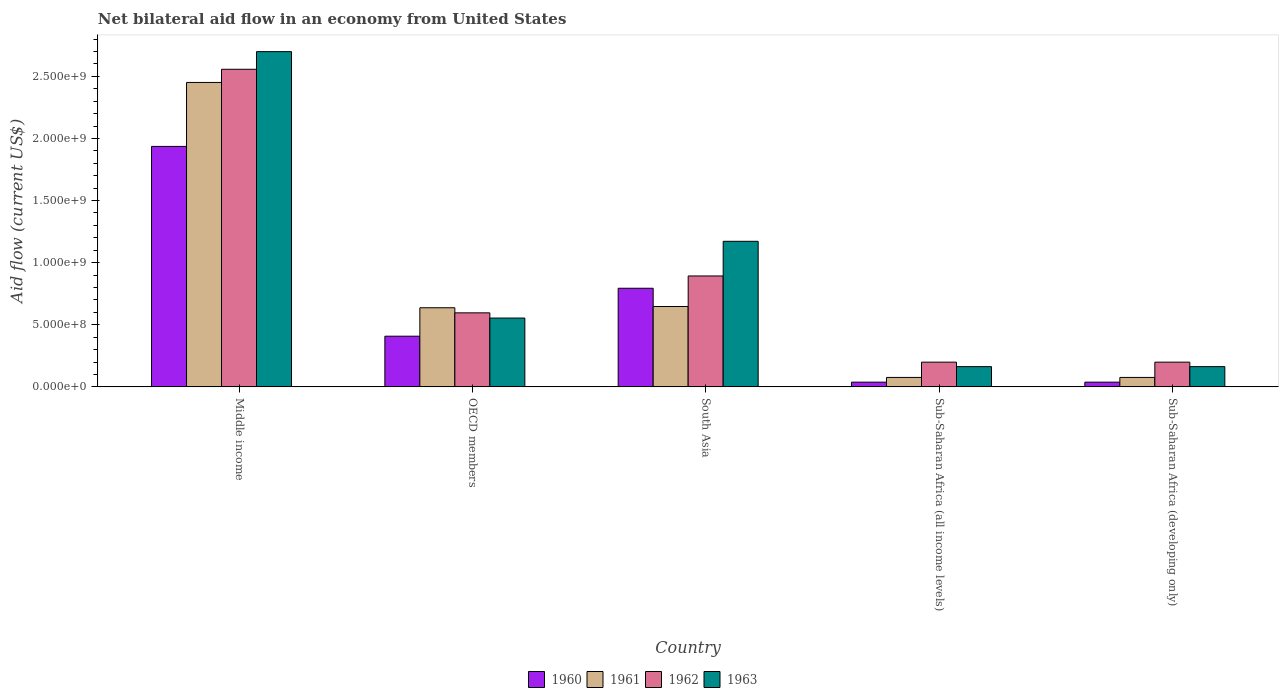How many different coloured bars are there?
Your answer should be compact. 4. How many bars are there on the 2nd tick from the left?
Your answer should be very brief. 4. What is the label of the 1st group of bars from the left?
Offer a very short reply. Middle income. What is the net bilateral aid flow in 1960 in Sub-Saharan Africa (all income levels)?
Keep it short and to the point. 3.80e+07. Across all countries, what is the maximum net bilateral aid flow in 1962?
Your answer should be compact. 2.56e+09. Across all countries, what is the minimum net bilateral aid flow in 1963?
Provide a succinct answer. 1.63e+08. In which country was the net bilateral aid flow in 1960 minimum?
Your response must be concise. Sub-Saharan Africa (all income levels). What is the total net bilateral aid flow in 1962 in the graph?
Offer a terse response. 4.44e+09. What is the difference between the net bilateral aid flow in 1962 in Middle income and that in South Asia?
Give a very brief answer. 1.66e+09. What is the difference between the net bilateral aid flow in 1960 in South Asia and the net bilateral aid flow in 1963 in Sub-Saharan Africa (developing only)?
Ensure brevity in your answer.  6.31e+08. What is the average net bilateral aid flow in 1961 per country?
Offer a terse response. 7.77e+08. What is the difference between the net bilateral aid flow of/in 1961 and net bilateral aid flow of/in 1962 in OECD members?
Your answer should be compact. 4.10e+07. In how many countries, is the net bilateral aid flow in 1961 greater than 500000000 US$?
Make the answer very short. 3. What is the ratio of the net bilateral aid flow in 1960 in Middle income to that in South Asia?
Your answer should be very brief. 2.44. What is the difference between the highest and the second highest net bilateral aid flow in 1962?
Your response must be concise. 1.96e+09. What is the difference between the highest and the lowest net bilateral aid flow in 1963?
Your answer should be very brief. 2.54e+09. Is the sum of the net bilateral aid flow in 1962 in Middle income and South Asia greater than the maximum net bilateral aid flow in 1961 across all countries?
Provide a succinct answer. Yes. Is it the case that in every country, the sum of the net bilateral aid flow in 1961 and net bilateral aid flow in 1963 is greater than the sum of net bilateral aid flow in 1962 and net bilateral aid flow in 1960?
Your response must be concise. No. What does the 3rd bar from the right in Sub-Saharan Africa (all income levels) represents?
Offer a terse response. 1961. How many bars are there?
Make the answer very short. 20. How many countries are there in the graph?
Your answer should be very brief. 5. What is the difference between two consecutive major ticks on the Y-axis?
Keep it short and to the point. 5.00e+08. Are the values on the major ticks of Y-axis written in scientific E-notation?
Your answer should be compact. Yes. Does the graph contain any zero values?
Offer a very short reply. No. Where does the legend appear in the graph?
Offer a very short reply. Bottom center. How are the legend labels stacked?
Your answer should be compact. Horizontal. What is the title of the graph?
Offer a terse response. Net bilateral aid flow in an economy from United States. What is the label or title of the Y-axis?
Make the answer very short. Aid flow (current US$). What is the Aid flow (current US$) of 1960 in Middle income?
Offer a very short reply. 1.94e+09. What is the Aid flow (current US$) of 1961 in Middle income?
Keep it short and to the point. 2.45e+09. What is the Aid flow (current US$) in 1962 in Middle income?
Offer a terse response. 2.56e+09. What is the Aid flow (current US$) of 1963 in Middle income?
Offer a terse response. 2.70e+09. What is the Aid flow (current US$) in 1960 in OECD members?
Ensure brevity in your answer.  4.08e+08. What is the Aid flow (current US$) in 1961 in OECD members?
Offer a very short reply. 6.37e+08. What is the Aid flow (current US$) of 1962 in OECD members?
Your answer should be compact. 5.96e+08. What is the Aid flow (current US$) of 1963 in OECD members?
Give a very brief answer. 5.54e+08. What is the Aid flow (current US$) of 1960 in South Asia?
Your answer should be compact. 7.94e+08. What is the Aid flow (current US$) in 1961 in South Asia?
Keep it short and to the point. 6.47e+08. What is the Aid flow (current US$) of 1962 in South Asia?
Keep it short and to the point. 8.93e+08. What is the Aid flow (current US$) of 1963 in South Asia?
Offer a terse response. 1.17e+09. What is the Aid flow (current US$) in 1960 in Sub-Saharan Africa (all income levels)?
Your answer should be very brief. 3.80e+07. What is the Aid flow (current US$) of 1961 in Sub-Saharan Africa (all income levels)?
Your answer should be very brief. 7.60e+07. What is the Aid flow (current US$) of 1962 in Sub-Saharan Africa (all income levels)?
Your answer should be very brief. 1.99e+08. What is the Aid flow (current US$) in 1963 in Sub-Saharan Africa (all income levels)?
Keep it short and to the point. 1.63e+08. What is the Aid flow (current US$) of 1960 in Sub-Saharan Africa (developing only)?
Your answer should be compact. 3.80e+07. What is the Aid flow (current US$) in 1961 in Sub-Saharan Africa (developing only)?
Provide a short and direct response. 7.60e+07. What is the Aid flow (current US$) of 1962 in Sub-Saharan Africa (developing only)?
Your response must be concise. 1.99e+08. What is the Aid flow (current US$) of 1963 in Sub-Saharan Africa (developing only)?
Offer a very short reply. 1.63e+08. Across all countries, what is the maximum Aid flow (current US$) in 1960?
Provide a short and direct response. 1.94e+09. Across all countries, what is the maximum Aid flow (current US$) in 1961?
Your response must be concise. 2.45e+09. Across all countries, what is the maximum Aid flow (current US$) of 1962?
Offer a terse response. 2.56e+09. Across all countries, what is the maximum Aid flow (current US$) of 1963?
Make the answer very short. 2.70e+09. Across all countries, what is the minimum Aid flow (current US$) in 1960?
Your answer should be very brief. 3.80e+07. Across all countries, what is the minimum Aid flow (current US$) of 1961?
Your answer should be compact. 7.60e+07. Across all countries, what is the minimum Aid flow (current US$) of 1962?
Provide a short and direct response. 1.99e+08. Across all countries, what is the minimum Aid flow (current US$) of 1963?
Your answer should be very brief. 1.63e+08. What is the total Aid flow (current US$) of 1960 in the graph?
Your answer should be very brief. 3.21e+09. What is the total Aid flow (current US$) in 1961 in the graph?
Provide a short and direct response. 3.89e+09. What is the total Aid flow (current US$) of 1962 in the graph?
Ensure brevity in your answer.  4.44e+09. What is the total Aid flow (current US$) in 1963 in the graph?
Make the answer very short. 4.75e+09. What is the difference between the Aid flow (current US$) in 1960 in Middle income and that in OECD members?
Keep it short and to the point. 1.53e+09. What is the difference between the Aid flow (current US$) of 1961 in Middle income and that in OECD members?
Your response must be concise. 1.81e+09. What is the difference between the Aid flow (current US$) of 1962 in Middle income and that in OECD members?
Provide a short and direct response. 1.96e+09. What is the difference between the Aid flow (current US$) of 1963 in Middle income and that in OECD members?
Your answer should be very brief. 2.14e+09. What is the difference between the Aid flow (current US$) in 1960 in Middle income and that in South Asia?
Provide a short and direct response. 1.14e+09. What is the difference between the Aid flow (current US$) in 1961 in Middle income and that in South Asia?
Provide a short and direct response. 1.80e+09. What is the difference between the Aid flow (current US$) in 1962 in Middle income and that in South Asia?
Offer a terse response. 1.66e+09. What is the difference between the Aid flow (current US$) of 1963 in Middle income and that in South Asia?
Your answer should be very brief. 1.53e+09. What is the difference between the Aid flow (current US$) in 1960 in Middle income and that in Sub-Saharan Africa (all income levels)?
Make the answer very short. 1.90e+09. What is the difference between the Aid flow (current US$) in 1961 in Middle income and that in Sub-Saharan Africa (all income levels)?
Offer a very short reply. 2.38e+09. What is the difference between the Aid flow (current US$) of 1962 in Middle income and that in Sub-Saharan Africa (all income levels)?
Provide a succinct answer. 2.36e+09. What is the difference between the Aid flow (current US$) of 1963 in Middle income and that in Sub-Saharan Africa (all income levels)?
Your response must be concise. 2.54e+09. What is the difference between the Aid flow (current US$) in 1960 in Middle income and that in Sub-Saharan Africa (developing only)?
Ensure brevity in your answer.  1.90e+09. What is the difference between the Aid flow (current US$) of 1961 in Middle income and that in Sub-Saharan Africa (developing only)?
Provide a short and direct response. 2.38e+09. What is the difference between the Aid flow (current US$) in 1962 in Middle income and that in Sub-Saharan Africa (developing only)?
Keep it short and to the point. 2.36e+09. What is the difference between the Aid flow (current US$) in 1963 in Middle income and that in Sub-Saharan Africa (developing only)?
Give a very brief answer. 2.54e+09. What is the difference between the Aid flow (current US$) of 1960 in OECD members and that in South Asia?
Make the answer very short. -3.86e+08. What is the difference between the Aid flow (current US$) of 1961 in OECD members and that in South Asia?
Give a very brief answer. -1.00e+07. What is the difference between the Aid flow (current US$) of 1962 in OECD members and that in South Asia?
Provide a succinct answer. -2.97e+08. What is the difference between the Aid flow (current US$) of 1963 in OECD members and that in South Asia?
Provide a short and direct response. -6.18e+08. What is the difference between the Aid flow (current US$) of 1960 in OECD members and that in Sub-Saharan Africa (all income levels)?
Ensure brevity in your answer.  3.70e+08. What is the difference between the Aid flow (current US$) in 1961 in OECD members and that in Sub-Saharan Africa (all income levels)?
Offer a terse response. 5.61e+08. What is the difference between the Aid flow (current US$) in 1962 in OECD members and that in Sub-Saharan Africa (all income levels)?
Provide a succinct answer. 3.97e+08. What is the difference between the Aid flow (current US$) in 1963 in OECD members and that in Sub-Saharan Africa (all income levels)?
Make the answer very short. 3.91e+08. What is the difference between the Aid flow (current US$) in 1960 in OECD members and that in Sub-Saharan Africa (developing only)?
Ensure brevity in your answer.  3.70e+08. What is the difference between the Aid flow (current US$) in 1961 in OECD members and that in Sub-Saharan Africa (developing only)?
Your answer should be very brief. 5.61e+08. What is the difference between the Aid flow (current US$) in 1962 in OECD members and that in Sub-Saharan Africa (developing only)?
Your response must be concise. 3.97e+08. What is the difference between the Aid flow (current US$) of 1963 in OECD members and that in Sub-Saharan Africa (developing only)?
Make the answer very short. 3.91e+08. What is the difference between the Aid flow (current US$) in 1960 in South Asia and that in Sub-Saharan Africa (all income levels)?
Your answer should be very brief. 7.56e+08. What is the difference between the Aid flow (current US$) of 1961 in South Asia and that in Sub-Saharan Africa (all income levels)?
Provide a short and direct response. 5.71e+08. What is the difference between the Aid flow (current US$) of 1962 in South Asia and that in Sub-Saharan Africa (all income levels)?
Offer a very short reply. 6.94e+08. What is the difference between the Aid flow (current US$) of 1963 in South Asia and that in Sub-Saharan Africa (all income levels)?
Your answer should be compact. 1.01e+09. What is the difference between the Aid flow (current US$) in 1960 in South Asia and that in Sub-Saharan Africa (developing only)?
Your response must be concise. 7.56e+08. What is the difference between the Aid flow (current US$) in 1961 in South Asia and that in Sub-Saharan Africa (developing only)?
Provide a succinct answer. 5.71e+08. What is the difference between the Aid flow (current US$) in 1962 in South Asia and that in Sub-Saharan Africa (developing only)?
Offer a terse response. 6.94e+08. What is the difference between the Aid flow (current US$) in 1963 in South Asia and that in Sub-Saharan Africa (developing only)?
Provide a short and direct response. 1.01e+09. What is the difference between the Aid flow (current US$) in 1960 in Sub-Saharan Africa (all income levels) and that in Sub-Saharan Africa (developing only)?
Offer a terse response. 0. What is the difference between the Aid flow (current US$) in 1961 in Sub-Saharan Africa (all income levels) and that in Sub-Saharan Africa (developing only)?
Keep it short and to the point. 0. What is the difference between the Aid flow (current US$) in 1962 in Sub-Saharan Africa (all income levels) and that in Sub-Saharan Africa (developing only)?
Provide a succinct answer. 0. What is the difference between the Aid flow (current US$) in 1960 in Middle income and the Aid flow (current US$) in 1961 in OECD members?
Your answer should be very brief. 1.30e+09. What is the difference between the Aid flow (current US$) of 1960 in Middle income and the Aid flow (current US$) of 1962 in OECD members?
Your answer should be very brief. 1.34e+09. What is the difference between the Aid flow (current US$) in 1960 in Middle income and the Aid flow (current US$) in 1963 in OECD members?
Make the answer very short. 1.38e+09. What is the difference between the Aid flow (current US$) of 1961 in Middle income and the Aid flow (current US$) of 1962 in OECD members?
Keep it short and to the point. 1.86e+09. What is the difference between the Aid flow (current US$) of 1961 in Middle income and the Aid flow (current US$) of 1963 in OECD members?
Your answer should be very brief. 1.90e+09. What is the difference between the Aid flow (current US$) in 1962 in Middle income and the Aid flow (current US$) in 1963 in OECD members?
Your response must be concise. 2.00e+09. What is the difference between the Aid flow (current US$) in 1960 in Middle income and the Aid flow (current US$) in 1961 in South Asia?
Ensure brevity in your answer.  1.29e+09. What is the difference between the Aid flow (current US$) in 1960 in Middle income and the Aid flow (current US$) in 1962 in South Asia?
Offer a terse response. 1.04e+09. What is the difference between the Aid flow (current US$) of 1960 in Middle income and the Aid flow (current US$) of 1963 in South Asia?
Provide a short and direct response. 7.64e+08. What is the difference between the Aid flow (current US$) in 1961 in Middle income and the Aid flow (current US$) in 1962 in South Asia?
Ensure brevity in your answer.  1.56e+09. What is the difference between the Aid flow (current US$) of 1961 in Middle income and the Aid flow (current US$) of 1963 in South Asia?
Your answer should be very brief. 1.28e+09. What is the difference between the Aid flow (current US$) of 1962 in Middle income and the Aid flow (current US$) of 1963 in South Asia?
Keep it short and to the point. 1.38e+09. What is the difference between the Aid flow (current US$) of 1960 in Middle income and the Aid flow (current US$) of 1961 in Sub-Saharan Africa (all income levels)?
Keep it short and to the point. 1.86e+09. What is the difference between the Aid flow (current US$) of 1960 in Middle income and the Aid flow (current US$) of 1962 in Sub-Saharan Africa (all income levels)?
Offer a terse response. 1.74e+09. What is the difference between the Aid flow (current US$) in 1960 in Middle income and the Aid flow (current US$) in 1963 in Sub-Saharan Africa (all income levels)?
Offer a very short reply. 1.77e+09. What is the difference between the Aid flow (current US$) in 1961 in Middle income and the Aid flow (current US$) in 1962 in Sub-Saharan Africa (all income levels)?
Your answer should be very brief. 2.25e+09. What is the difference between the Aid flow (current US$) in 1961 in Middle income and the Aid flow (current US$) in 1963 in Sub-Saharan Africa (all income levels)?
Ensure brevity in your answer.  2.29e+09. What is the difference between the Aid flow (current US$) in 1962 in Middle income and the Aid flow (current US$) in 1963 in Sub-Saharan Africa (all income levels)?
Your answer should be very brief. 2.39e+09. What is the difference between the Aid flow (current US$) of 1960 in Middle income and the Aid flow (current US$) of 1961 in Sub-Saharan Africa (developing only)?
Ensure brevity in your answer.  1.86e+09. What is the difference between the Aid flow (current US$) of 1960 in Middle income and the Aid flow (current US$) of 1962 in Sub-Saharan Africa (developing only)?
Offer a terse response. 1.74e+09. What is the difference between the Aid flow (current US$) of 1960 in Middle income and the Aid flow (current US$) of 1963 in Sub-Saharan Africa (developing only)?
Make the answer very short. 1.77e+09. What is the difference between the Aid flow (current US$) of 1961 in Middle income and the Aid flow (current US$) of 1962 in Sub-Saharan Africa (developing only)?
Ensure brevity in your answer.  2.25e+09. What is the difference between the Aid flow (current US$) in 1961 in Middle income and the Aid flow (current US$) in 1963 in Sub-Saharan Africa (developing only)?
Your answer should be compact. 2.29e+09. What is the difference between the Aid flow (current US$) in 1962 in Middle income and the Aid flow (current US$) in 1963 in Sub-Saharan Africa (developing only)?
Make the answer very short. 2.39e+09. What is the difference between the Aid flow (current US$) in 1960 in OECD members and the Aid flow (current US$) in 1961 in South Asia?
Ensure brevity in your answer.  -2.39e+08. What is the difference between the Aid flow (current US$) in 1960 in OECD members and the Aid flow (current US$) in 1962 in South Asia?
Keep it short and to the point. -4.85e+08. What is the difference between the Aid flow (current US$) of 1960 in OECD members and the Aid flow (current US$) of 1963 in South Asia?
Your response must be concise. -7.64e+08. What is the difference between the Aid flow (current US$) of 1961 in OECD members and the Aid flow (current US$) of 1962 in South Asia?
Keep it short and to the point. -2.56e+08. What is the difference between the Aid flow (current US$) of 1961 in OECD members and the Aid flow (current US$) of 1963 in South Asia?
Ensure brevity in your answer.  -5.35e+08. What is the difference between the Aid flow (current US$) of 1962 in OECD members and the Aid flow (current US$) of 1963 in South Asia?
Offer a very short reply. -5.76e+08. What is the difference between the Aid flow (current US$) in 1960 in OECD members and the Aid flow (current US$) in 1961 in Sub-Saharan Africa (all income levels)?
Your answer should be compact. 3.32e+08. What is the difference between the Aid flow (current US$) of 1960 in OECD members and the Aid flow (current US$) of 1962 in Sub-Saharan Africa (all income levels)?
Give a very brief answer. 2.09e+08. What is the difference between the Aid flow (current US$) of 1960 in OECD members and the Aid flow (current US$) of 1963 in Sub-Saharan Africa (all income levels)?
Give a very brief answer. 2.45e+08. What is the difference between the Aid flow (current US$) of 1961 in OECD members and the Aid flow (current US$) of 1962 in Sub-Saharan Africa (all income levels)?
Offer a terse response. 4.38e+08. What is the difference between the Aid flow (current US$) in 1961 in OECD members and the Aid flow (current US$) in 1963 in Sub-Saharan Africa (all income levels)?
Your response must be concise. 4.74e+08. What is the difference between the Aid flow (current US$) in 1962 in OECD members and the Aid flow (current US$) in 1963 in Sub-Saharan Africa (all income levels)?
Keep it short and to the point. 4.33e+08. What is the difference between the Aid flow (current US$) of 1960 in OECD members and the Aid flow (current US$) of 1961 in Sub-Saharan Africa (developing only)?
Give a very brief answer. 3.32e+08. What is the difference between the Aid flow (current US$) of 1960 in OECD members and the Aid flow (current US$) of 1962 in Sub-Saharan Africa (developing only)?
Ensure brevity in your answer.  2.09e+08. What is the difference between the Aid flow (current US$) in 1960 in OECD members and the Aid flow (current US$) in 1963 in Sub-Saharan Africa (developing only)?
Ensure brevity in your answer.  2.45e+08. What is the difference between the Aid flow (current US$) of 1961 in OECD members and the Aid flow (current US$) of 1962 in Sub-Saharan Africa (developing only)?
Keep it short and to the point. 4.38e+08. What is the difference between the Aid flow (current US$) of 1961 in OECD members and the Aid flow (current US$) of 1963 in Sub-Saharan Africa (developing only)?
Your response must be concise. 4.74e+08. What is the difference between the Aid flow (current US$) in 1962 in OECD members and the Aid flow (current US$) in 1963 in Sub-Saharan Africa (developing only)?
Make the answer very short. 4.33e+08. What is the difference between the Aid flow (current US$) of 1960 in South Asia and the Aid flow (current US$) of 1961 in Sub-Saharan Africa (all income levels)?
Keep it short and to the point. 7.18e+08. What is the difference between the Aid flow (current US$) in 1960 in South Asia and the Aid flow (current US$) in 1962 in Sub-Saharan Africa (all income levels)?
Ensure brevity in your answer.  5.95e+08. What is the difference between the Aid flow (current US$) in 1960 in South Asia and the Aid flow (current US$) in 1963 in Sub-Saharan Africa (all income levels)?
Offer a very short reply. 6.31e+08. What is the difference between the Aid flow (current US$) of 1961 in South Asia and the Aid flow (current US$) of 1962 in Sub-Saharan Africa (all income levels)?
Your answer should be very brief. 4.48e+08. What is the difference between the Aid flow (current US$) in 1961 in South Asia and the Aid flow (current US$) in 1963 in Sub-Saharan Africa (all income levels)?
Offer a terse response. 4.84e+08. What is the difference between the Aid flow (current US$) in 1962 in South Asia and the Aid flow (current US$) in 1963 in Sub-Saharan Africa (all income levels)?
Give a very brief answer. 7.30e+08. What is the difference between the Aid flow (current US$) in 1960 in South Asia and the Aid flow (current US$) in 1961 in Sub-Saharan Africa (developing only)?
Your answer should be very brief. 7.18e+08. What is the difference between the Aid flow (current US$) of 1960 in South Asia and the Aid flow (current US$) of 1962 in Sub-Saharan Africa (developing only)?
Provide a short and direct response. 5.95e+08. What is the difference between the Aid flow (current US$) of 1960 in South Asia and the Aid flow (current US$) of 1963 in Sub-Saharan Africa (developing only)?
Ensure brevity in your answer.  6.31e+08. What is the difference between the Aid flow (current US$) in 1961 in South Asia and the Aid flow (current US$) in 1962 in Sub-Saharan Africa (developing only)?
Provide a short and direct response. 4.48e+08. What is the difference between the Aid flow (current US$) of 1961 in South Asia and the Aid flow (current US$) of 1963 in Sub-Saharan Africa (developing only)?
Provide a succinct answer. 4.84e+08. What is the difference between the Aid flow (current US$) in 1962 in South Asia and the Aid flow (current US$) in 1963 in Sub-Saharan Africa (developing only)?
Ensure brevity in your answer.  7.30e+08. What is the difference between the Aid flow (current US$) in 1960 in Sub-Saharan Africa (all income levels) and the Aid flow (current US$) in 1961 in Sub-Saharan Africa (developing only)?
Ensure brevity in your answer.  -3.80e+07. What is the difference between the Aid flow (current US$) in 1960 in Sub-Saharan Africa (all income levels) and the Aid flow (current US$) in 1962 in Sub-Saharan Africa (developing only)?
Offer a terse response. -1.61e+08. What is the difference between the Aid flow (current US$) of 1960 in Sub-Saharan Africa (all income levels) and the Aid flow (current US$) of 1963 in Sub-Saharan Africa (developing only)?
Your answer should be very brief. -1.25e+08. What is the difference between the Aid flow (current US$) of 1961 in Sub-Saharan Africa (all income levels) and the Aid flow (current US$) of 1962 in Sub-Saharan Africa (developing only)?
Offer a very short reply. -1.23e+08. What is the difference between the Aid flow (current US$) of 1961 in Sub-Saharan Africa (all income levels) and the Aid flow (current US$) of 1963 in Sub-Saharan Africa (developing only)?
Provide a short and direct response. -8.70e+07. What is the difference between the Aid flow (current US$) in 1962 in Sub-Saharan Africa (all income levels) and the Aid flow (current US$) in 1963 in Sub-Saharan Africa (developing only)?
Make the answer very short. 3.60e+07. What is the average Aid flow (current US$) in 1960 per country?
Offer a terse response. 6.43e+08. What is the average Aid flow (current US$) in 1961 per country?
Your response must be concise. 7.77e+08. What is the average Aid flow (current US$) in 1962 per country?
Your response must be concise. 8.89e+08. What is the average Aid flow (current US$) of 1963 per country?
Your answer should be very brief. 9.50e+08. What is the difference between the Aid flow (current US$) of 1960 and Aid flow (current US$) of 1961 in Middle income?
Your response must be concise. -5.15e+08. What is the difference between the Aid flow (current US$) of 1960 and Aid flow (current US$) of 1962 in Middle income?
Your answer should be compact. -6.21e+08. What is the difference between the Aid flow (current US$) in 1960 and Aid flow (current US$) in 1963 in Middle income?
Provide a succinct answer. -7.63e+08. What is the difference between the Aid flow (current US$) of 1961 and Aid flow (current US$) of 1962 in Middle income?
Offer a terse response. -1.06e+08. What is the difference between the Aid flow (current US$) in 1961 and Aid flow (current US$) in 1963 in Middle income?
Ensure brevity in your answer.  -2.48e+08. What is the difference between the Aid flow (current US$) in 1962 and Aid flow (current US$) in 1963 in Middle income?
Give a very brief answer. -1.42e+08. What is the difference between the Aid flow (current US$) of 1960 and Aid flow (current US$) of 1961 in OECD members?
Offer a very short reply. -2.29e+08. What is the difference between the Aid flow (current US$) in 1960 and Aid flow (current US$) in 1962 in OECD members?
Provide a succinct answer. -1.88e+08. What is the difference between the Aid flow (current US$) in 1960 and Aid flow (current US$) in 1963 in OECD members?
Keep it short and to the point. -1.46e+08. What is the difference between the Aid flow (current US$) in 1961 and Aid flow (current US$) in 1962 in OECD members?
Make the answer very short. 4.10e+07. What is the difference between the Aid flow (current US$) in 1961 and Aid flow (current US$) in 1963 in OECD members?
Offer a terse response. 8.30e+07. What is the difference between the Aid flow (current US$) of 1962 and Aid flow (current US$) of 1963 in OECD members?
Your answer should be compact. 4.20e+07. What is the difference between the Aid flow (current US$) in 1960 and Aid flow (current US$) in 1961 in South Asia?
Provide a short and direct response. 1.47e+08. What is the difference between the Aid flow (current US$) in 1960 and Aid flow (current US$) in 1962 in South Asia?
Give a very brief answer. -9.90e+07. What is the difference between the Aid flow (current US$) of 1960 and Aid flow (current US$) of 1963 in South Asia?
Give a very brief answer. -3.78e+08. What is the difference between the Aid flow (current US$) in 1961 and Aid flow (current US$) in 1962 in South Asia?
Offer a terse response. -2.46e+08. What is the difference between the Aid flow (current US$) of 1961 and Aid flow (current US$) of 1963 in South Asia?
Provide a succinct answer. -5.25e+08. What is the difference between the Aid flow (current US$) in 1962 and Aid flow (current US$) in 1963 in South Asia?
Your answer should be very brief. -2.79e+08. What is the difference between the Aid flow (current US$) of 1960 and Aid flow (current US$) of 1961 in Sub-Saharan Africa (all income levels)?
Give a very brief answer. -3.80e+07. What is the difference between the Aid flow (current US$) of 1960 and Aid flow (current US$) of 1962 in Sub-Saharan Africa (all income levels)?
Offer a very short reply. -1.61e+08. What is the difference between the Aid flow (current US$) of 1960 and Aid flow (current US$) of 1963 in Sub-Saharan Africa (all income levels)?
Provide a succinct answer. -1.25e+08. What is the difference between the Aid flow (current US$) of 1961 and Aid flow (current US$) of 1962 in Sub-Saharan Africa (all income levels)?
Offer a very short reply. -1.23e+08. What is the difference between the Aid flow (current US$) in 1961 and Aid flow (current US$) in 1963 in Sub-Saharan Africa (all income levels)?
Keep it short and to the point. -8.70e+07. What is the difference between the Aid flow (current US$) of 1962 and Aid flow (current US$) of 1963 in Sub-Saharan Africa (all income levels)?
Provide a succinct answer. 3.60e+07. What is the difference between the Aid flow (current US$) in 1960 and Aid flow (current US$) in 1961 in Sub-Saharan Africa (developing only)?
Make the answer very short. -3.80e+07. What is the difference between the Aid flow (current US$) in 1960 and Aid flow (current US$) in 1962 in Sub-Saharan Africa (developing only)?
Make the answer very short. -1.61e+08. What is the difference between the Aid flow (current US$) of 1960 and Aid flow (current US$) of 1963 in Sub-Saharan Africa (developing only)?
Ensure brevity in your answer.  -1.25e+08. What is the difference between the Aid flow (current US$) in 1961 and Aid flow (current US$) in 1962 in Sub-Saharan Africa (developing only)?
Your answer should be compact. -1.23e+08. What is the difference between the Aid flow (current US$) of 1961 and Aid flow (current US$) of 1963 in Sub-Saharan Africa (developing only)?
Make the answer very short. -8.70e+07. What is the difference between the Aid flow (current US$) of 1962 and Aid flow (current US$) of 1963 in Sub-Saharan Africa (developing only)?
Your answer should be compact. 3.60e+07. What is the ratio of the Aid flow (current US$) of 1960 in Middle income to that in OECD members?
Your answer should be compact. 4.75. What is the ratio of the Aid flow (current US$) of 1961 in Middle income to that in OECD members?
Ensure brevity in your answer.  3.85. What is the ratio of the Aid flow (current US$) in 1962 in Middle income to that in OECD members?
Ensure brevity in your answer.  4.29. What is the ratio of the Aid flow (current US$) in 1963 in Middle income to that in OECD members?
Offer a terse response. 4.87. What is the ratio of the Aid flow (current US$) in 1960 in Middle income to that in South Asia?
Offer a terse response. 2.44. What is the ratio of the Aid flow (current US$) of 1961 in Middle income to that in South Asia?
Your answer should be very brief. 3.79. What is the ratio of the Aid flow (current US$) of 1962 in Middle income to that in South Asia?
Your response must be concise. 2.86. What is the ratio of the Aid flow (current US$) in 1963 in Middle income to that in South Asia?
Offer a terse response. 2.3. What is the ratio of the Aid flow (current US$) in 1960 in Middle income to that in Sub-Saharan Africa (all income levels)?
Give a very brief answer. 50.95. What is the ratio of the Aid flow (current US$) of 1961 in Middle income to that in Sub-Saharan Africa (all income levels)?
Your answer should be very brief. 32.25. What is the ratio of the Aid flow (current US$) in 1962 in Middle income to that in Sub-Saharan Africa (all income levels)?
Provide a short and direct response. 12.85. What is the ratio of the Aid flow (current US$) in 1963 in Middle income to that in Sub-Saharan Africa (all income levels)?
Provide a short and direct response. 16.56. What is the ratio of the Aid flow (current US$) in 1960 in Middle income to that in Sub-Saharan Africa (developing only)?
Your answer should be very brief. 50.95. What is the ratio of the Aid flow (current US$) of 1961 in Middle income to that in Sub-Saharan Africa (developing only)?
Offer a terse response. 32.25. What is the ratio of the Aid flow (current US$) in 1962 in Middle income to that in Sub-Saharan Africa (developing only)?
Your answer should be compact. 12.85. What is the ratio of the Aid flow (current US$) in 1963 in Middle income to that in Sub-Saharan Africa (developing only)?
Keep it short and to the point. 16.56. What is the ratio of the Aid flow (current US$) of 1960 in OECD members to that in South Asia?
Provide a succinct answer. 0.51. What is the ratio of the Aid flow (current US$) in 1961 in OECD members to that in South Asia?
Provide a succinct answer. 0.98. What is the ratio of the Aid flow (current US$) of 1962 in OECD members to that in South Asia?
Offer a very short reply. 0.67. What is the ratio of the Aid flow (current US$) of 1963 in OECD members to that in South Asia?
Provide a short and direct response. 0.47. What is the ratio of the Aid flow (current US$) in 1960 in OECD members to that in Sub-Saharan Africa (all income levels)?
Provide a succinct answer. 10.74. What is the ratio of the Aid flow (current US$) of 1961 in OECD members to that in Sub-Saharan Africa (all income levels)?
Keep it short and to the point. 8.38. What is the ratio of the Aid flow (current US$) in 1962 in OECD members to that in Sub-Saharan Africa (all income levels)?
Keep it short and to the point. 3. What is the ratio of the Aid flow (current US$) in 1963 in OECD members to that in Sub-Saharan Africa (all income levels)?
Offer a very short reply. 3.4. What is the ratio of the Aid flow (current US$) of 1960 in OECD members to that in Sub-Saharan Africa (developing only)?
Your answer should be compact. 10.74. What is the ratio of the Aid flow (current US$) in 1961 in OECD members to that in Sub-Saharan Africa (developing only)?
Give a very brief answer. 8.38. What is the ratio of the Aid flow (current US$) of 1962 in OECD members to that in Sub-Saharan Africa (developing only)?
Your response must be concise. 3. What is the ratio of the Aid flow (current US$) of 1963 in OECD members to that in Sub-Saharan Africa (developing only)?
Ensure brevity in your answer.  3.4. What is the ratio of the Aid flow (current US$) in 1960 in South Asia to that in Sub-Saharan Africa (all income levels)?
Your response must be concise. 20.89. What is the ratio of the Aid flow (current US$) of 1961 in South Asia to that in Sub-Saharan Africa (all income levels)?
Keep it short and to the point. 8.51. What is the ratio of the Aid flow (current US$) in 1962 in South Asia to that in Sub-Saharan Africa (all income levels)?
Provide a succinct answer. 4.49. What is the ratio of the Aid flow (current US$) in 1963 in South Asia to that in Sub-Saharan Africa (all income levels)?
Provide a succinct answer. 7.19. What is the ratio of the Aid flow (current US$) of 1960 in South Asia to that in Sub-Saharan Africa (developing only)?
Keep it short and to the point. 20.89. What is the ratio of the Aid flow (current US$) in 1961 in South Asia to that in Sub-Saharan Africa (developing only)?
Make the answer very short. 8.51. What is the ratio of the Aid flow (current US$) of 1962 in South Asia to that in Sub-Saharan Africa (developing only)?
Your answer should be very brief. 4.49. What is the ratio of the Aid flow (current US$) of 1963 in South Asia to that in Sub-Saharan Africa (developing only)?
Provide a succinct answer. 7.19. What is the ratio of the Aid flow (current US$) in 1960 in Sub-Saharan Africa (all income levels) to that in Sub-Saharan Africa (developing only)?
Provide a succinct answer. 1. What is the ratio of the Aid flow (current US$) in 1961 in Sub-Saharan Africa (all income levels) to that in Sub-Saharan Africa (developing only)?
Make the answer very short. 1. What is the difference between the highest and the second highest Aid flow (current US$) of 1960?
Give a very brief answer. 1.14e+09. What is the difference between the highest and the second highest Aid flow (current US$) in 1961?
Provide a short and direct response. 1.80e+09. What is the difference between the highest and the second highest Aid flow (current US$) of 1962?
Provide a short and direct response. 1.66e+09. What is the difference between the highest and the second highest Aid flow (current US$) in 1963?
Provide a short and direct response. 1.53e+09. What is the difference between the highest and the lowest Aid flow (current US$) of 1960?
Keep it short and to the point. 1.90e+09. What is the difference between the highest and the lowest Aid flow (current US$) in 1961?
Your answer should be compact. 2.38e+09. What is the difference between the highest and the lowest Aid flow (current US$) in 1962?
Provide a short and direct response. 2.36e+09. What is the difference between the highest and the lowest Aid flow (current US$) of 1963?
Offer a terse response. 2.54e+09. 